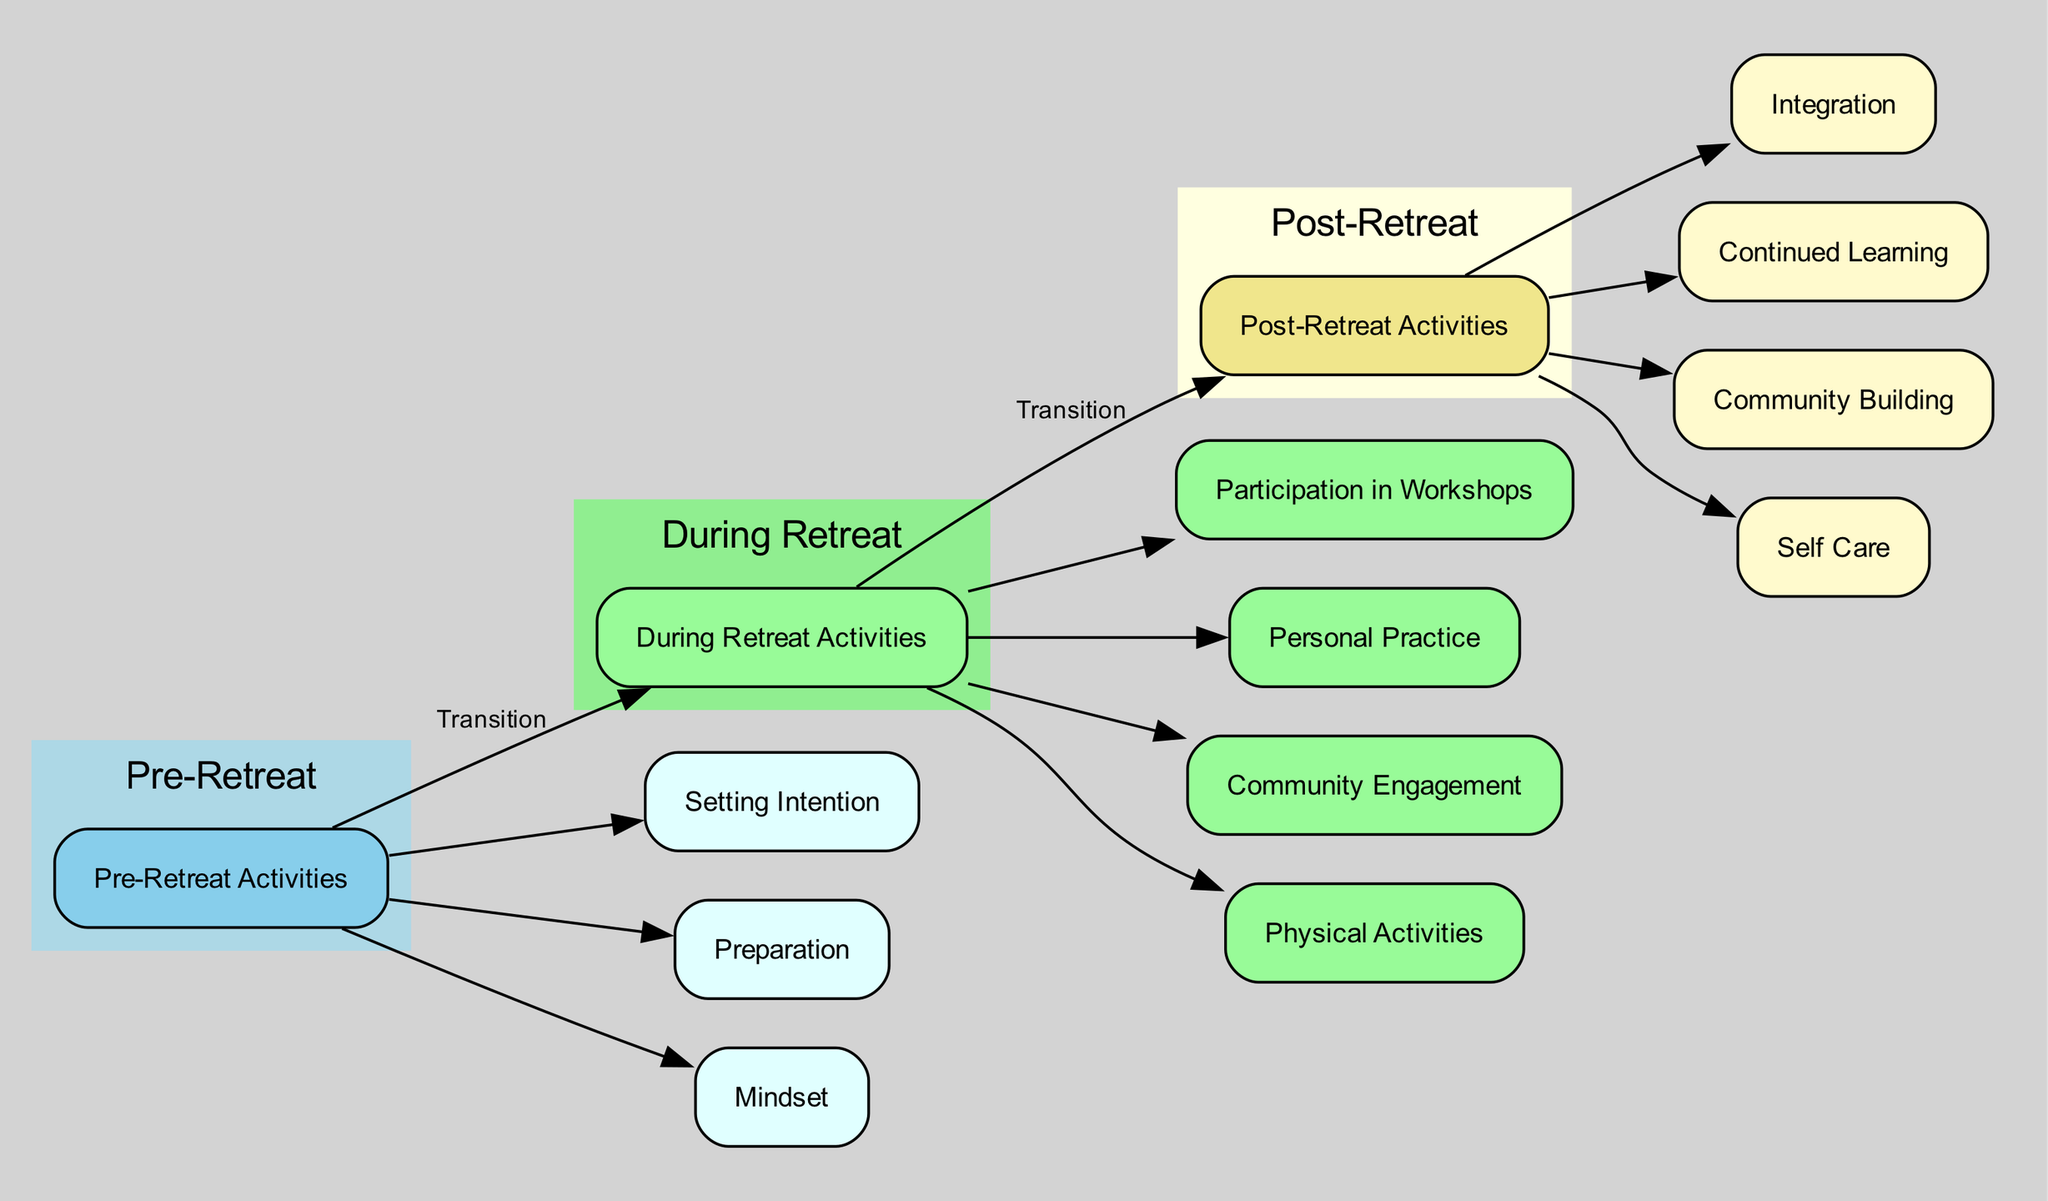What are the main stages of the retreat journey represented in the diagram? The diagram includes three main stages: Pre-Retreat Activities, During Retreat Activities, and Post-Retreat Activities, which are clearly labeled as clusters in the diagram.
Answer: Pre-Retreat Activities, During Retreat Activities, Post-Retreat Activities How many activities are listed under Post-Retreat Activities? By visually inspecting the Post-Retreat section of the diagram, there are four activities: Integration, Continued Learning, Community Building, and Self Care. Each is represented as a node connected to the Post-Retreat Activities node.
Answer: 4 What is the relationship between "Preparation" and "Setting Intention"? Both "Preparation" and "Setting Intention" are connected to the "Pre-Retreat Activities" node as separate branches, indicating that they are both important components of the Pre-Retreat phase.
Answer: Both branches of Pre-Retreat Activities Which activity involves attending guided meditation workshops? This activity is labeled as "Mindfulness Sessions" under the "Participation in Workshops" section during the retreat activities.
Answer: Mindfulness Sessions What is required for "Physical Readiness" prior to the retreat? Under the "Physical Readiness" section, it specifies two main requirements: a switch to a vegetarian or light diet a week before the retreat and ensuring adequate rest to align the body and mind.
Answer: Switch to vegetarian diet, ensure adequate rest Which node emphasizes cultivating an open mind? The "Expectation Management" node under "Mindset" during the Pre-Retreat Activities emphasizes cultivating an open mind without stringent expectations before attending the retreat.
Answer: Expectation Management What kind of community activity is mentioned during the retreat? The diagram lists "Seva," which involves participating in community service and is categorized under "Community Engagement" during the retreat activities.
Answer: Seva What is the first activity listed for Post-Retreat Activities? The diagram indicates that the first activity listed under Post-Retreat Activities is "Integration," which includes journaling and reflecting on learnings from the retreat experience.
Answer: Integration 